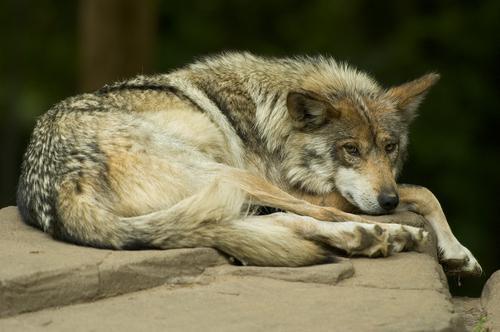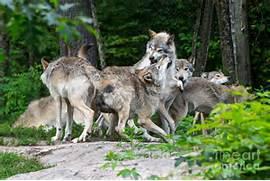The first image is the image on the left, the second image is the image on the right. Evaluate the accuracy of this statement regarding the images: "The left image contains exactly one wolf.". Is it true? Answer yes or no. Yes. The first image is the image on the left, the second image is the image on the right. Given the left and right images, does the statement "There is only one wolf in at least one of the images." hold true? Answer yes or no. Yes. 